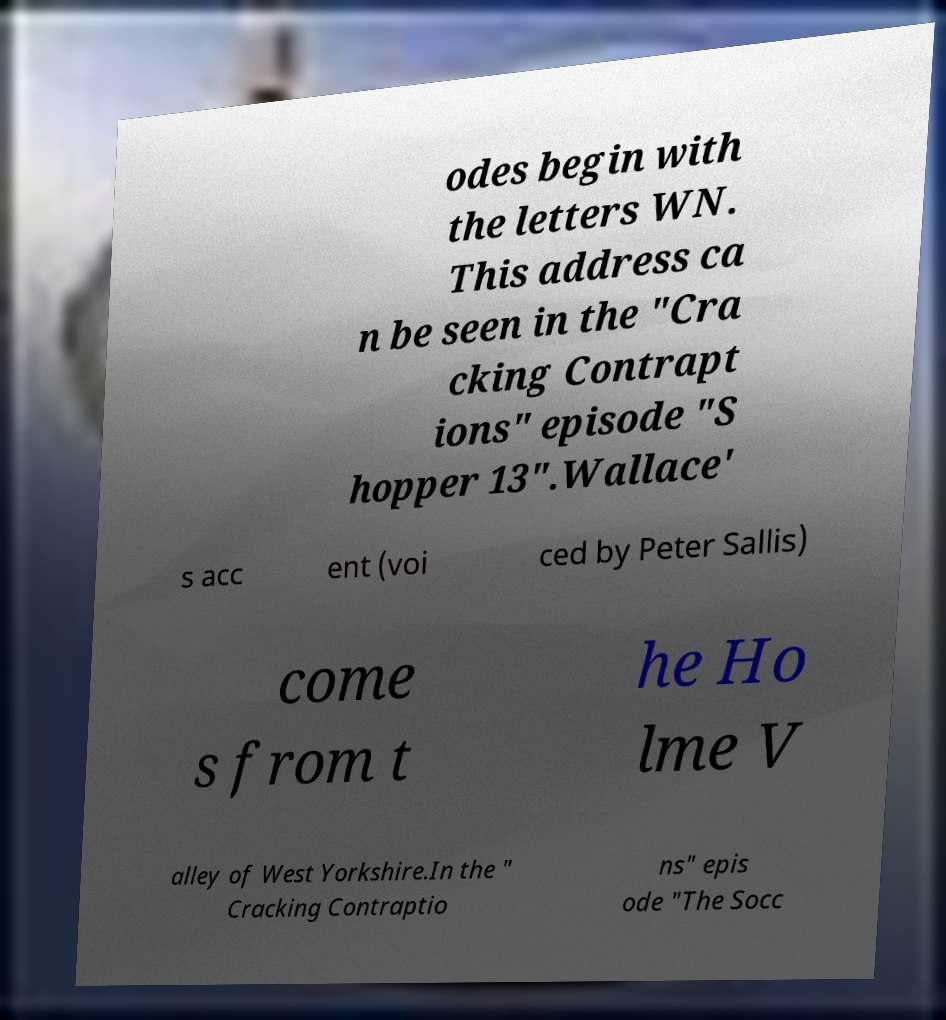Please identify and transcribe the text found in this image. odes begin with the letters WN. This address ca n be seen in the "Cra cking Contrapt ions" episode "S hopper 13".Wallace' s acc ent (voi ced by Peter Sallis) come s from t he Ho lme V alley of West Yorkshire.In the " Cracking Contraptio ns" epis ode "The Socc 